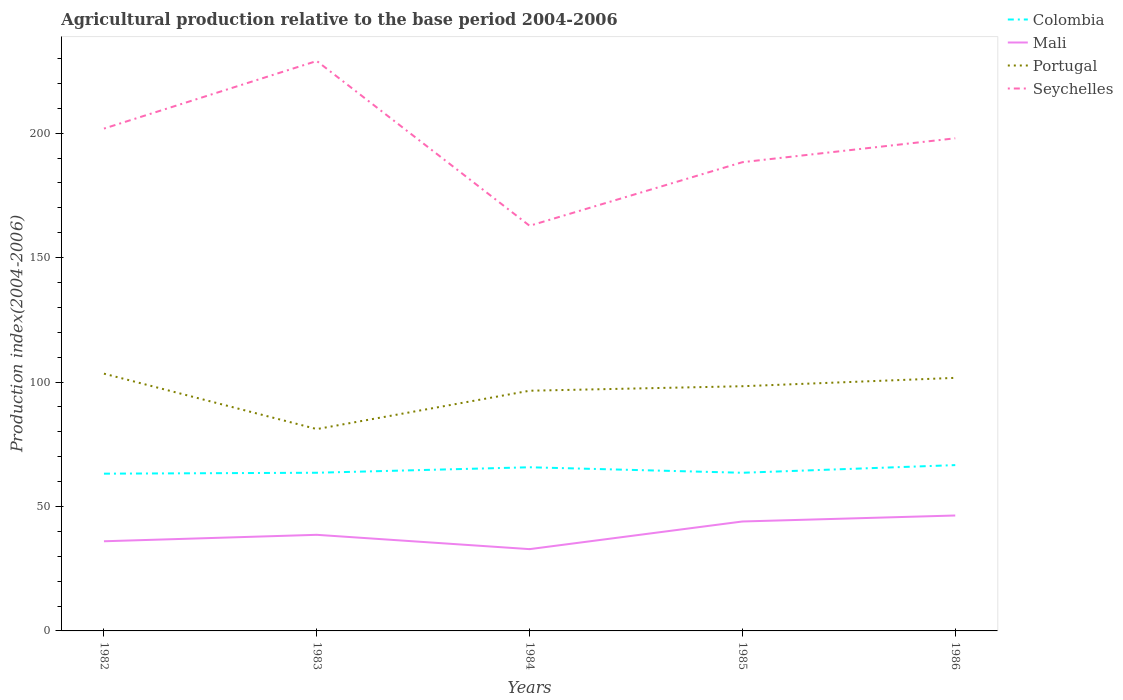Does the line corresponding to Portugal intersect with the line corresponding to Seychelles?
Provide a short and direct response. No. Across all years, what is the maximum agricultural production index in Mali?
Provide a short and direct response. 32.86. In which year was the agricultural production index in Mali maximum?
Give a very brief answer. 1984. What is the total agricultural production index in Portugal in the graph?
Your answer should be compact. -17.22. What is the difference between the highest and the second highest agricultural production index in Mali?
Offer a terse response. 13.51. Is the agricultural production index in Colombia strictly greater than the agricultural production index in Seychelles over the years?
Your answer should be very brief. Yes. How many lines are there?
Your response must be concise. 4. What is the difference between two consecutive major ticks on the Y-axis?
Your response must be concise. 50. Does the graph contain grids?
Ensure brevity in your answer.  No. How many legend labels are there?
Provide a short and direct response. 4. How are the legend labels stacked?
Keep it short and to the point. Vertical. What is the title of the graph?
Offer a very short reply. Agricultural production relative to the base period 2004-2006. What is the label or title of the X-axis?
Your answer should be compact. Years. What is the label or title of the Y-axis?
Keep it short and to the point. Production index(2004-2006). What is the Production index(2004-2006) in Colombia in 1982?
Give a very brief answer. 63.18. What is the Production index(2004-2006) in Mali in 1982?
Provide a short and direct response. 36.02. What is the Production index(2004-2006) of Portugal in 1982?
Provide a succinct answer. 103.36. What is the Production index(2004-2006) of Seychelles in 1982?
Provide a short and direct response. 201.82. What is the Production index(2004-2006) in Colombia in 1983?
Your answer should be very brief. 63.55. What is the Production index(2004-2006) in Mali in 1983?
Offer a terse response. 38.61. What is the Production index(2004-2006) of Portugal in 1983?
Give a very brief answer. 81.09. What is the Production index(2004-2006) of Seychelles in 1983?
Give a very brief answer. 228.98. What is the Production index(2004-2006) of Colombia in 1984?
Provide a succinct answer. 65.75. What is the Production index(2004-2006) of Mali in 1984?
Provide a short and direct response. 32.86. What is the Production index(2004-2006) in Portugal in 1984?
Ensure brevity in your answer.  96.5. What is the Production index(2004-2006) in Seychelles in 1984?
Offer a very short reply. 162.77. What is the Production index(2004-2006) in Colombia in 1985?
Ensure brevity in your answer.  63.54. What is the Production index(2004-2006) in Mali in 1985?
Make the answer very short. 43.97. What is the Production index(2004-2006) of Portugal in 1985?
Make the answer very short. 98.31. What is the Production index(2004-2006) in Seychelles in 1985?
Your response must be concise. 188.32. What is the Production index(2004-2006) of Colombia in 1986?
Provide a short and direct response. 66.62. What is the Production index(2004-2006) in Mali in 1986?
Give a very brief answer. 46.37. What is the Production index(2004-2006) of Portugal in 1986?
Your response must be concise. 101.67. What is the Production index(2004-2006) of Seychelles in 1986?
Keep it short and to the point. 197.92. Across all years, what is the maximum Production index(2004-2006) of Colombia?
Your response must be concise. 66.62. Across all years, what is the maximum Production index(2004-2006) of Mali?
Ensure brevity in your answer.  46.37. Across all years, what is the maximum Production index(2004-2006) of Portugal?
Your response must be concise. 103.36. Across all years, what is the maximum Production index(2004-2006) in Seychelles?
Your response must be concise. 228.98. Across all years, what is the minimum Production index(2004-2006) in Colombia?
Provide a short and direct response. 63.18. Across all years, what is the minimum Production index(2004-2006) in Mali?
Your answer should be very brief. 32.86. Across all years, what is the minimum Production index(2004-2006) in Portugal?
Provide a succinct answer. 81.09. Across all years, what is the minimum Production index(2004-2006) of Seychelles?
Provide a succinct answer. 162.77. What is the total Production index(2004-2006) in Colombia in the graph?
Make the answer very short. 322.64. What is the total Production index(2004-2006) of Mali in the graph?
Ensure brevity in your answer.  197.83. What is the total Production index(2004-2006) in Portugal in the graph?
Provide a succinct answer. 480.93. What is the total Production index(2004-2006) in Seychelles in the graph?
Provide a succinct answer. 979.81. What is the difference between the Production index(2004-2006) in Colombia in 1982 and that in 1983?
Provide a succinct answer. -0.37. What is the difference between the Production index(2004-2006) of Mali in 1982 and that in 1983?
Your answer should be very brief. -2.59. What is the difference between the Production index(2004-2006) in Portugal in 1982 and that in 1983?
Your response must be concise. 22.27. What is the difference between the Production index(2004-2006) of Seychelles in 1982 and that in 1983?
Provide a succinct answer. -27.16. What is the difference between the Production index(2004-2006) in Colombia in 1982 and that in 1984?
Keep it short and to the point. -2.57. What is the difference between the Production index(2004-2006) of Mali in 1982 and that in 1984?
Ensure brevity in your answer.  3.16. What is the difference between the Production index(2004-2006) in Portugal in 1982 and that in 1984?
Make the answer very short. 6.86. What is the difference between the Production index(2004-2006) in Seychelles in 1982 and that in 1984?
Provide a succinct answer. 39.05. What is the difference between the Production index(2004-2006) in Colombia in 1982 and that in 1985?
Provide a short and direct response. -0.36. What is the difference between the Production index(2004-2006) of Mali in 1982 and that in 1985?
Offer a terse response. -7.95. What is the difference between the Production index(2004-2006) of Portugal in 1982 and that in 1985?
Offer a very short reply. 5.05. What is the difference between the Production index(2004-2006) in Colombia in 1982 and that in 1986?
Make the answer very short. -3.44. What is the difference between the Production index(2004-2006) in Mali in 1982 and that in 1986?
Your response must be concise. -10.35. What is the difference between the Production index(2004-2006) in Portugal in 1982 and that in 1986?
Your answer should be compact. 1.69. What is the difference between the Production index(2004-2006) in Seychelles in 1982 and that in 1986?
Offer a terse response. 3.9. What is the difference between the Production index(2004-2006) in Colombia in 1983 and that in 1984?
Provide a succinct answer. -2.2. What is the difference between the Production index(2004-2006) of Mali in 1983 and that in 1984?
Offer a very short reply. 5.75. What is the difference between the Production index(2004-2006) in Portugal in 1983 and that in 1984?
Offer a terse response. -15.41. What is the difference between the Production index(2004-2006) in Seychelles in 1983 and that in 1984?
Your answer should be compact. 66.21. What is the difference between the Production index(2004-2006) in Mali in 1983 and that in 1985?
Your answer should be compact. -5.36. What is the difference between the Production index(2004-2006) of Portugal in 1983 and that in 1985?
Your response must be concise. -17.22. What is the difference between the Production index(2004-2006) in Seychelles in 1983 and that in 1985?
Keep it short and to the point. 40.66. What is the difference between the Production index(2004-2006) of Colombia in 1983 and that in 1986?
Offer a terse response. -3.07. What is the difference between the Production index(2004-2006) in Mali in 1983 and that in 1986?
Offer a very short reply. -7.76. What is the difference between the Production index(2004-2006) of Portugal in 1983 and that in 1986?
Your response must be concise. -20.58. What is the difference between the Production index(2004-2006) in Seychelles in 1983 and that in 1986?
Offer a very short reply. 31.06. What is the difference between the Production index(2004-2006) of Colombia in 1984 and that in 1985?
Provide a short and direct response. 2.21. What is the difference between the Production index(2004-2006) in Mali in 1984 and that in 1985?
Your answer should be compact. -11.11. What is the difference between the Production index(2004-2006) of Portugal in 1984 and that in 1985?
Your answer should be very brief. -1.81. What is the difference between the Production index(2004-2006) of Seychelles in 1984 and that in 1985?
Keep it short and to the point. -25.55. What is the difference between the Production index(2004-2006) of Colombia in 1984 and that in 1986?
Make the answer very short. -0.87. What is the difference between the Production index(2004-2006) in Mali in 1984 and that in 1986?
Make the answer very short. -13.51. What is the difference between the Production index(2004-2006) in Portugal in 1984 and that in 1986?
Provide a short and direct response. -5.17. What is the difference between the Production index(2004-2006) of Seychelles in 1984 and that in 1986?
Give a very brief answer. -35.15. What is the difference between the Production index(2004-2006) of Colombia in 1985 and that in 1986?
Offer a very short reply. -3.08. What is the difference between the Production index(2004-2006) of Mali in 1985 and that in 1986?
Your answer should be compact. -2.4. What is the difference between the Production index(2004-2006) in Portugal in 1985 and that in 1986?
Your answer should be very brief. -3.36. What is the difference between the Production index(2004-2006) of Colombia in 1982 and the Production index(2004-2006) of Mali in 1983?
Keep it short and to the point. 24.57. What is the difference between the Production index(2004-2006) in Colombia in 1982 and the Production index(2004-2006) in Portugal in 1983?
Keep it short and to the point. -17.91. What is the difference between the Production index(2004-2006) of Colombia in 1982 and the Production index(2004-2006) of Seychelles in 1983?
Make the answer very short. -165.8. What is the difference between the Production index(2004-2006) in Mali in 1982 and the Production index(2004-2006) in Portugal in 1983?
Make the answer very short. -45.07. What is the difference between the Production index(2004-2006) of Mali in 1982 and the Production index(2004-2006) of Seychelles in 1983?
Make the answer very short. -192.96. What is the difference between the Production index(2004-2006) of Portugal in 1982 and the Production index(2004-2006) of Seychelles in 1983?
Keep it short and to the point. -125.62. What is the difference between the Production index(2004-2006) of Colombia in 1982 and the Production index(2004-2006) of Mali in 1984?
Keep it short and to the point. 30.32. What is the difference between the Production index(2004-2006) of Colombia in 1982 and the Production index(2004-2006) of Portugal in 1984?
Keep it short and to the point. -33.32. What is the difference between the Production index(2004-2006) in Colombia in 1982 and the Production index(2004-2006) in Seychelles in 1984?
Provide a succinct answer. -99.59. What is the difference between the Production index(2004-2006) in Mali in 1982 and the Production index(2004-2006) in Portugal in 1984?
Your answer should be very brief. -60.48. What is the difference between the Production index(2004-2006) of Mali in 1982 and the Production index(2004-2006) of Seychelles in 1984?
Your answer should be compact. -126.75. What is the difference between the Production index(2004-2006) in Portugal in 1982 and the Production index(2004-2006) in Seychelles in 1984?
Ensure brevity in your answer.  -59.41. What is the difference between the Production index(2004-2006) in Colombia in 1982 and the Production index(2004-2006) in Mali in 1985?
Your response must be concise. 19.21. What is the difference between the Production index(2004-2006) in Colombia in 1982 and the Production index(2004-2006) in Portugal in 1985?
Provide a succinct answer. -35.13. What is the difference between the Production index(2004-2006) of Colombia in 1982 and the Production index(2004-2006) of Seychelles in 1985?
Give a very brief answer. -125.14. What is the difference between the Production index(2004-2006) in Mali in 1982 and the Production index(2004-2006) in Portugal in 1985?
Your answer should be compact. -62.29. What is the difference between the Production index(2004-2006) in Mali in 1982 and the Production index(2004-2006) in Seychelles in 1985?
Provide a succinct answer. -152.3. What is the difference between the Production index(2004-2006) in Portugal in 1982 and the Production index(2004-2006) in Seychelles in 1985?
Offer a very short reply. -84.96. What is the difference between the Production index(2004-2006) of Colombia in 1982 and the Production index(2004-2006) of Mali in 1986?
Offer a very short reply. 16.81. What is the difference between the Production index(2004-2006) of Colombia in 1982 and the Production index(2004-2006) of Portugal in 1986?
Your response must be concise. -38.49. What is the difference between the Production index(2004-2006) of Colombia in 1982 and the Production index(2004-2006) of Seychelles in 1986?
Your response must be concise. -134.74. What is the difference between the Production index(2004-2006) in Mali in 1982 and the Production index(2004-2006) in Portugal in 1986?
Ensure brevity in your answer.  -65.65. What is the difference between the Production index(2004-2006) of Mali in 1982 and the Production index(2004-2006) of Seychelles in 1986?
Give a very brief answer. -161.9. What is the difference between the Production index(2004-2006) of Portugal in 1982 and the Production index(2004-2006) of Seychelles in 1986?
Offer a terse response. -94.56. What is the difference between the Production index(2004-2006) in Colombia in 1983 and the Production index(2004-2006) in Mali in 1984?
Offer a terse response. 30.69. What is the difference between the Production index(2004-2006) of Colombia in 1983 and the Production index(2004-2006) of Portugal in 1984?
Your answer should be very brief. -32.95. What is the difference between the Production index(2004-2006) of Colombia in 1983 and the Production index(2004-2006) of Seychelles in 1984?
Your answer should be compact. -99.22. What is the difference between the Production index(2004-2006) in Mali in 1983 and the Production index(2004-2006) in Portugal in 1984?
Give a very brief answer. -57.89. What is the difference between the Production index(2004-2006) of Mali in 1983 and the Production index(2004-2006) of Seychelles in 1984?
Ensure brevity in your answer.  -124.16. What is the difference between the Production index(2004-2006) of Portugal in 1983 and the Production index(2004-2006) of Seychelles in 1984?
Your answer should be compact. -81.68. What is the difference between the Production index(2004-2006) in Colombia in 1983 and the Production index(2004-2006) in Mali in 1985?
Offer a very short reply. 19.58. What is the difference between the Production index(2004-2006) in Colombia in 1983 and the Production index(2004-2006) in Portugal in 1985?
Make the answer very short. -34.76. What is the difference between the Production index(2004-2006) of Colombia in 1983 and the Production index(2004-2006) of Seychelles in 1985?
Make the answer very short. -124.77. What is the difference between the Production index(2004-2006) in Mali in 1983 and the Production index(2004-2006) in Portugal in 1985?
Provide a short and direct response. -59.7. What is the difference between the Production index(2004-2006) in Mali in 1983 and the Production index(2004-2006) in Seychelles in 1985?
Keep it short and to the point. -149.71. What is the difference between the Production index(2004-2006) of Portugal in 1983 and the Production index(2004-2006) of Seychelles in 1985?
Keep it short and to the point. -107.23. What is the difference between the Production index(2004-2006) of Colombia in 1983 and the Production index(2004-2006) of Mali in 1986?
Make the answer very short. 17.18. What is the difference between the Production index(2004-2006) in Colombia in 1983 and the Production index(2004-2006) in Portugal in 1986?
Provide a short and direct response. -38.12. What is the difference between the Production index(2004-2006) of Colombia in 1983 and the Production index(2004-2006) of Seychelles in 1986?
Offer a very short reply. -134.37. What is the difference between the Production index(2004-2006) in Mali in 1983 and the Production index(2004-2006) in Portugal in 1986?
Offer a very short reply. -63.06. What is the difference between the Production index(2004-2006) in Mali in 1983 and the Production index(2004-2006) in Seychelles in 1986?
Offer a terse response. -159.31. What is the difference between the Production index(2004-2006) in Portugal in 1983 and the Production index(2004-2006) in Seychelles in 1986?
Make the answer very short. -116.83. What is the difference between the Production index(2004-2006) of Colombia in 1984 and the Production index(2004-2006) of Mali in 1985?
Ensure brevity in your answer.  21.78. What is the difference between the Production index(2004-2006) of Colombia in 1984 and the Production index(2004-2006) of Portugal in 1985?
Keep it short and to the point. -32.56. What is the difference between the Production index(2004-2006) in Colombia in 1984 and the Production index(2004-2006) in Seychelles in 1985?
Your answer should be very brief. -122.57. What is the difference between the Production index(2004-2006) of Mali in 1984 and the Production index(2004-2006) of Portugal in 1985?
Keep it short and to the point. -65.45. What is the difference between the Production index(2004-2006) of Mali in 1984 and the Production index(2004-2006) of Seychelles in 1985?
Provide a short and direct response. -155.46. What is the difference between the Production index(2004-2006) in Portugal in 1984 and the Production index(2004-2006) in Seychelles in 1985?
Give a very brief answer. -91.82. What is the difference between the Production index(2004-2006) in Colombia in 1984 and the Production index(2004-2006) in Mali in 1986?
Your answer should be very brief. 19.38. What is the difference between the Production index(2004-2006) of Colombia in 1984 and the Production index(2004-2006) of Portugal in 1986?
Your answer should be very brief. -35.92. What is the difference between the Production index(2004-2006) of Colombia in 1984 and the Production index(2004-2006) of Seychelles in 1986?
Offer a terse response. -132.17. What is the difference between the Production index(2004-2006) in Mali in 1984 and the Production index(2004-2006) in Portugal in 1986?
Your answer should be very brief. -68.81. What is the difference between the Production index(2004-2006) of Mali in 1984 and the Production index(2004-2006) of Seychelles in 1986?
Provide a succinct answer. -165.06. What is the difference between the Production index(2004-2006) in Portugal in 1984 and the Production index(2004-2006) in Seychelles in 1986?
Your answer should be compact. -101.42. What is the difference between the Production index(2004-2006) in Colombia in 1985 and the Production index(2004-2006) in Mali in 1986?
Offer a terse response. 17.17. What is the difference between the Production index(2004-2006) in Colombia in 1985 and the Production index(2004-2006) in Portugal in 1986?
Your answer should be very brief. -38.13. What is the difference between the Production index(2004-2006) of Colombia in 1985 and the Production index(2004-2006) of Seychelles in 1986?
Ensure brevity in your answer.  -134.38. What is the difference between the Production index(2004-2006) of Mali in 1985 and the Production index(2004-2006) of Portugal in 1986?
Your answer should be very brief. -57.7. What is the difference between the Production index(2004-2006) of Mali in 1985 and the Production index(2004-2006) of Seychelles in 1986?
Provide a succinct answer. -153.95. What is the difference between the Production index(2004-2006) in Portugal in 1985 and the Production index(2004-2006) in Seychelles in 1986?
Provide a succinct answer. -99.61. What is the average Production index(2004-2006) in Colombia per year?
Make the answer very short. 64.53. What is the average Production index(2004-2006) in Mali per year?
Keep it short and to the point. 39.57. What is the average Production index(2004-2006) of Portugal per year?
Your response must be concise. 96.19. What is the average Production index(2004-2006) of Seychelles per year?
Your answer should be compact. 195.96. In the year 1982, what is the difference between the Production index(2004-2006) of Colombia and Production index(2004-2006) of Mali?
Ensure brevity in your answer.  27.16. In the year 1982, what is the difference between the Production index(2004-2006) in Colombia and Production index(2004-2006) in Portugal?
Your answer should be compact. -40.18. In the year 1982, what is the difference between the Production index(2004-2006) in Colombia and Production index(2004-2006) in Seychelles?
Give a very brief answer. -138.64. In the year 1982, what is the difference between the Production index(2004-2006) of Mali and Production index(2004-2006) of Portugal?
Your answer should be compact. -67.34. In the year 1982, what is the difference between the Production index(2004-2006) in Mali and Production index(2004-2006) in Seychelles?
Make the answer very short. -165.8. In the year 1982, what is the difference between the Production index(2004-2006) in Portugal and Production index(2004-2006) in Seychelles?
Give a very brief answer. -98.46. In the year 1983, what is the difference between the Production index(2004-2006) in Colombia and Production index(2004-2006) in Mali?
Provide a short and direct response. 24.94. In the year 1983, what is the difference between the Production index(2004-2006) of Colombia and Production index(2004-2006) of Portugal?
Make the answer very short. -17.54. In the year 1983, what is the difference between the Production index(2004-2006) of Colombia and Production index(2004-2006) of Seychelles?
Offer a terse response. -165.43. In the year 1983, what is the difference between the Production index(2004-2006) of Mali and Production index(2004-2006) of Portugal?
Provide a short and direct response. -42.48. In the year 1983, what is the difference between the Production index(2004-2006) in Mali and Production index(2004-2006) in Seychelles?
Your response must be concise. -190.37. In the year 1983, what is the difference between the Production index(2004-2006) of Portugal and Production index(2004-2006) of Seychelles?
Offer a very short reply. -147.89. In the year 1984, what is the difference between the Production index(2004-2006) of Colombia and Production index(2004-2006) of Mali?
Provide a succinct answer. 32.89. In the year 1984, what is the difference between the Production index(2004-2006) of Colombia and Production index(2004-2006) of Portugal?
Keep it short and to the point. -30.75. In the year 1984, what is the difference between the Production index(2004-2006) of Colombia and Production index(2004-2006) of Seychelles?
Provide a succinct answer. -97.02. In the year 1984, what is the difference between the Production index(2004-2006) of Mali and Production index(2004-2006) of Portugal?
Provide a succinct answer. -63.64. In the year 1984, what is the difference between the Production index(2004-2006) in Mali and Production index(2004-2006) in Seychelles?
Ensure brevity in your answer.  -129.91. In the year 1984, what is the difference between the Production index(2004-2006) of Portugal and Production index(2004-2006) of Seychelles?
Provide a succinct answer. -66.27. In the year 1985, what is the difference between the Production index(2004-2006) of Colombia and Production index(2004-2006) of Mali?
Keep it short and to the point. 19.57. In the year 1985, what is the difference between the Production index(2004-2006) in Colombia and Production index(2004-2006) in Portugal?
Keep it short and to the point. -34.77. In the year 1985, what is the difference between the Production index(2004-2006) of Colombia and Production index(2004-2006) of Seychelles?
Provide a succinct answer. -124.78. In the year 1985, what is the difference between the Production index(2004-2006) in Mali and Production index(2004-2006) in Portugal?
Your response must be concise. -54.34. In the year 1985, what is the difference between the Production index(2004-2006) in Mali and Production index(2004-2006) in Seychelles?
Make the answer very short. -144.35. In the year 1985, what is the difference between the Production index(2004-2006) of Portugal and Production index(2004-2006) of Seychelles?
Your response must be concise. -90.01. In the year 1986, what is the difference between the Production index(2004-2006) in Colombia and Production index(2004-2006) in Mali?
Make the answer very short. 20.25. In the year 1986, what is the difference between the Production index(2004-2006) of Colombia and Production index(2004-2006) of Portugal?
Your answer should be compact. -35.05. In the year 1986, what is the difference between the Production index(2004-2006) of Colombia and Production index(2004-2006) of Seychelles?
Your answer should be compact. -131.3. In the year 1986, what is the difference between the Production index(2004-2006) of Mali and Production index(2004-2006) of Portugal?
Provide a succinct answer. -55.3. In the year 1986, what is the difference between the Production index(2004-2006) in Mali and Production index(2004-2006) in Seychelles?
Give a very brief answer. -151.55. In the year 1986, what is the difference between the Production index(2004-2006) of Portugal and Production index(2004-2006) of Seychelles?
Provide a succinct answer. -96.25. What is the ratio of the Production index(2004-2006) of Colombia in 1982 to that in 1983?
Keep it short and to the point. 0.99. What is the ratio of the Production index(2004-2006) of Mali in 1982 to that in 1983?
Your answer should be very brief. 0.93. What is the ratio of the Production index(2004-2006) in Portugal in 1982 to that in 1983?
Your response must be concise. 1.27. What is the ratio of the Production index(2004-2006) of Seychelles in 1982 to that in 1983?
Offer a terse response. 0.88. What is the ratio of the Production index(2004-2006) of Colombia in 1982 to that in 1984?
Ensure brevity in your answer.  0.96. What is the ratio of the Production index(2004-2006) in Mali in 1982 to that in 1984?
Your answer should be very brief. 1.1. What is the ratio of the Production index(2004-2006) of Portugal in 1982 to that in 1984?
Give a very brief answer. 1.07. What is the ratio of the Production index(2004-2006) in Seychelles in 1982 to that in 1984?
Give a very brief answer. 1.24. What is the ratio of the Production index(2004-2006) of Colombia in 1982 to that in 1985?
Offer a very short reply. 0.99. What is the ratio of the Production index(2004-2006) in Mali in 1982 to that in 1985?
Your answer should be very brief. 0.82. What is the ratio of the Production index(2004-2006) in Portugal in 1982 to that in 1985?
Provide a short and direct response. 1.05. What is the ratio of the Production index(2004-2006) of Seychelles in 1982 to that in 1985?
Provide a short and direct response. 1.07. What is the ratio of the Production index(2004-2006) of Colombia in 1982 to that in 1986?
Make the answer very short. 0.95. What is the ratio of the Production index(2004-2006) in Mali in 1982 to that in 1986?
Your answer should be very brief. 0.78. What is the ratio of the Production index(2004-2006) of Portugal in 1982 to that in 1986?
Offer a terse response. 1.02. What is the ratio of the Production index(2004-2006) in Seychelles in 1982 to that in 1986?
Make the answer very short. 1.02. What is the ratio of the Production index(2004-2006) of Colombia in 1983 to that in 1984?
Offer a terse response. 0.97. What is the ratio of the Production index(2004-2006) in Mali in 1983 to that in 1984?
Your answer should be compact. 1.18. What is the ratio of the Production index(2004-2006) of Portugal in 1983 to that in 1984?
Your response must be concise. 0.84. What is the ratio of the Production index(2004-2006) of Seychelles in 1983 to that in 1984?
Give a very brief answer. 1.41. What is the ratio of the Production index(2004-2006) in Colombia in 1983 to that in 1985?
Offer a very short reply. 1. What is the ratio of the Production index(2004-2006) in Mali in 1983 to that in 1985?
Make the answer very short. 0.88. What is the ratio of the Production index(2004-2006) of Portugal in 1983 to that in 1985?
Make the answer very short. 0.82. What is the ratio of the Production index(2004-2006) in Seychelles in 1983 to that in 1985?
Provide a succinct answer. 1.22. What is the ratio of the Production index(2004-2006) of Colombia in 1983 to that in 1986?
Keep it short and to the point. 0.95. What is the ratio of the Production index(2004-2006) in Mali in 1983 to that in 1986?
Make the answer very short. 0.83. What is the ratio of the Production index(2004-2006) in Portugal in 1983 to that in 1986?
Ensure brevity in your answer.  0.8. What is the ratio of the Production index(2004-2006) in Seychelles in 1983 to that in 1986?
Ensure brevity in your answer.  1.16. What is the ratio of the Production index(2004-2006) of Colombia in 1984 to that in 1985?
Ensure brevity in your answer.  1.03. What is the ratio of the Production index(2004-2006) of Mali in 1984 to that in 1985?
Your answer should be compact. 0.75. What is the ratio of the Production index(2004-2006) of Portugal in 1984 to that in 1985?
Provide a short and direct response. 0.98. What is the ratio of the Production index(2004-2006) of Seychelles in 1984 to that in 1985?
Offer a very short reply. 0.86. What is the ratio of the Production index(2004-2006) in Colombia in 1984 to that in 1986?
Your answer should be very brief. 0.99. What is the ratio of the Production index(2004-2006) of Mali in 1984 to that in 1986?
Offer a very short reply. 0.71. What is the ratio of the Production index(2004-2006) of Portugal in 1984 to that in 1986?
Ensure brevity in your answer.  0.95. What is the ratio of the Production index(2004-2006) of Seychelles in 1984 to that in 1986?
Keep it short and to the point. 0.82. What is the ratio of the Production index(2004-2006) of Colombia in 1985 to that in 1986?
Your response must be concise. 0.95. What is the ratio of the Production index(2004-2006) in Mali in 1985 to that in 1986?
Give a very brief answer. 0.95. What is the ratio of the Production index(2004-2006) in Portugal in 1985 to that in 1986?
Ensure brevity in your answer.  0.97. What is the ratio of the Production index(2004-2006) of Seychelles in 1985 to that in 1986?
Make the answer very short. 0.95. What is the difference between the highest and the second highest Production index(2004-2006) in Colombia?
Make the answer very short. 0.87. What is the difference between the highest and the second highest Production index(2004-2006) in Portugal?
Provide a succinct answer. 1.69. What is the difference between the highest and the second highest Production index(2004-2006) of Seychelles?
Your response must be concise. 27.16. What is the difference between the highest and the lowest Production index(2004-2006) of Colombia?
Give a very brief answer. 3.44. What is the difference between the highest and the lowest Production index(2004-2006) of Mali?
Provide a short and direct response. 13.51. What is the difference between the highest and the lowest Production index(2004-2006) of Portugal?
Ensure brevity in your answer.  22.27. What is the difference between the highest and the lowest Production index(2004-2006) of Seychelles?
Offer a very short reply. 66.21. 